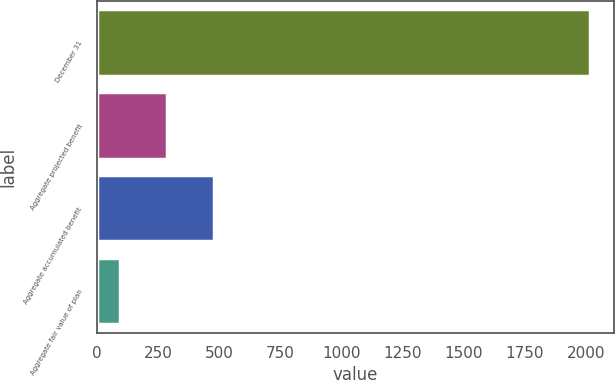<chart> <loc_0><loc_0><loc_500><loc_500><bar_chart><fcel>December 31<fcel>Aggregate projected benefit<fcel>Aggregate accumulated benefit<fcel>Aggregate fair value of plan<nl><fcel>2016<fcel>287.28<fcel>479.36<fcel>95.2<nl></chart> 